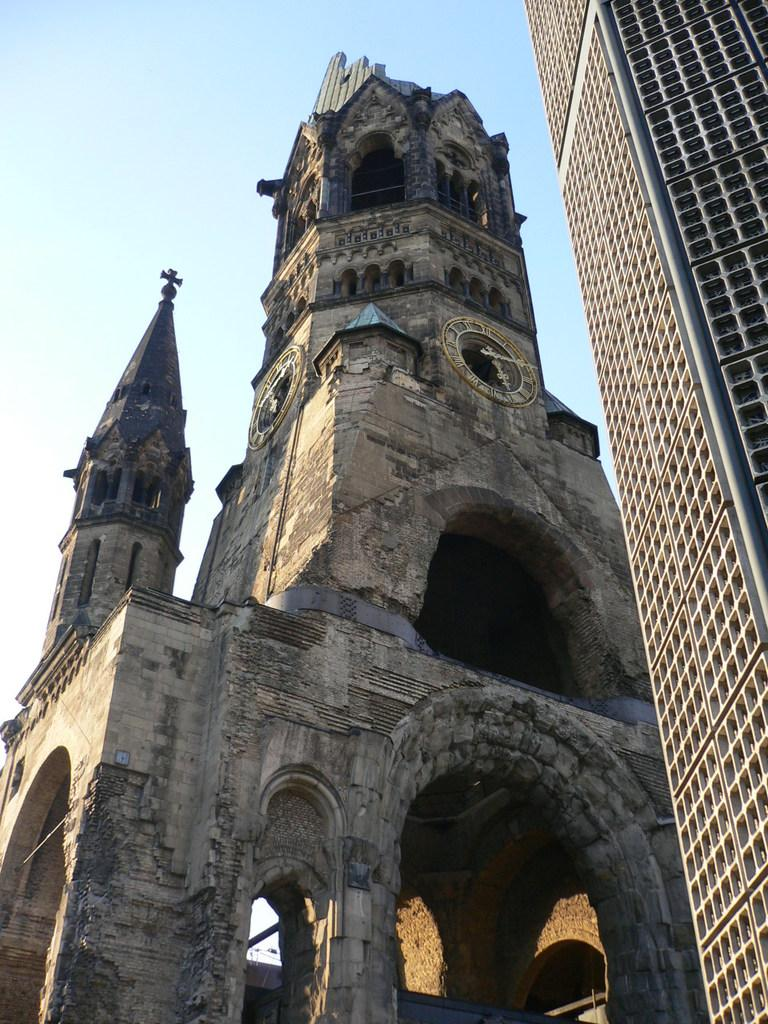What type of objects can be seen in the image? There are clocks and arches in the image. Where are these objects located? They are on a building, which is on the right side of the image. What else can be seen on the building? There are objects on the building. What is visible in the background of the image? The sky is visible in the background of the image. What rule is being enforced by the airplane in the image? There is no airplane present in the image, so no rule enforcement can be observed. Is there any smoke coming from the building in the image? There is no smoke visible in the image; the image only shows clocks, arches, and objects on a building. 